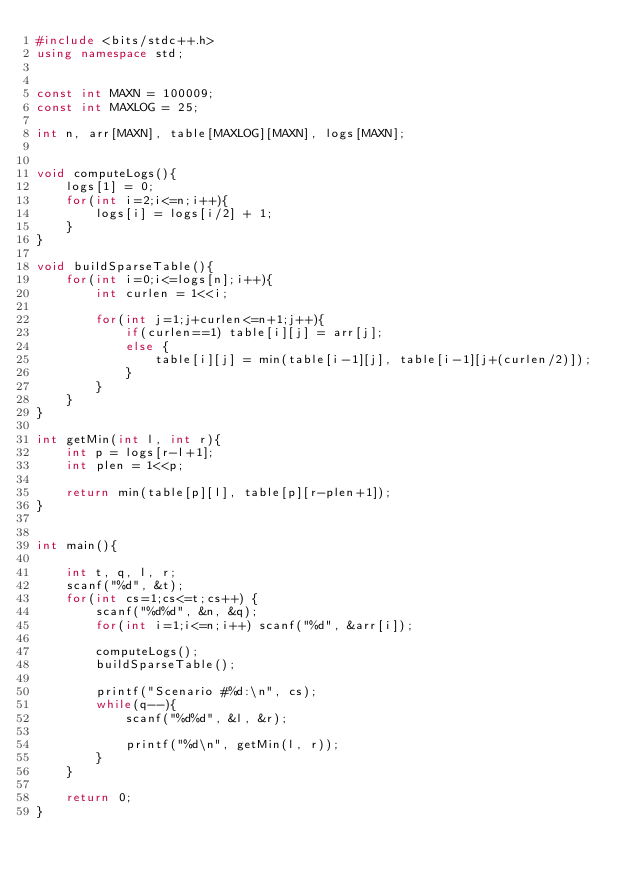Convert code to text. <code><loc_0><loc_0><loc_500><loc_500><_C++_>#include <bits/stdc++.h>
using namespace std;


const int MAXN = 100009;
const int MAXLOG = 25;

int n, arr[MAXN], table[MAXLOG][MAXN], logs[MAXN];


void computeLogs(){
	logs[1] = 0;
	for(int i=2;i<=n;i++){
		logs[i] = logs[i/2] + 1;
	}
}

void buildSparseTable(){
	for(int i=0;i<=logs[n];i++){
		int curlen = 1<<i;
		
		for(int j=1;j+curlen<=n+1;j++){
			if(curlen==1) table[i][j] = arr[j];
			else {
				table[i][j] = min(table[i-1][j], table[i-1][j+(curlen/2)]);
			}
		}
	}
}

int getMin(int l, int r){
	int p = logs[r-l+1];
	int plen = 1<<p;
	
	return min(table[p][l], table[p][r-plen+1]);
}


int main(){
	
	int t, q, l, r;
	scanf("%d", &t);
	for(int cs=1;cs<=t;cs++) {
		scanf("%d%d", &n, &q);
		for(int i=1;i<=n;i++) scanf("%d", &arr[i]);
		
		computeLogs();
		buildSparseTable();
		
		printf("Scenario #%d:\n", cs);
		while(q--){
			scanf("%d%d", &l, &r);
			
			printf("%d\n", getMin(l, r));
		}
	}
	
	return 0;
}
</code> 